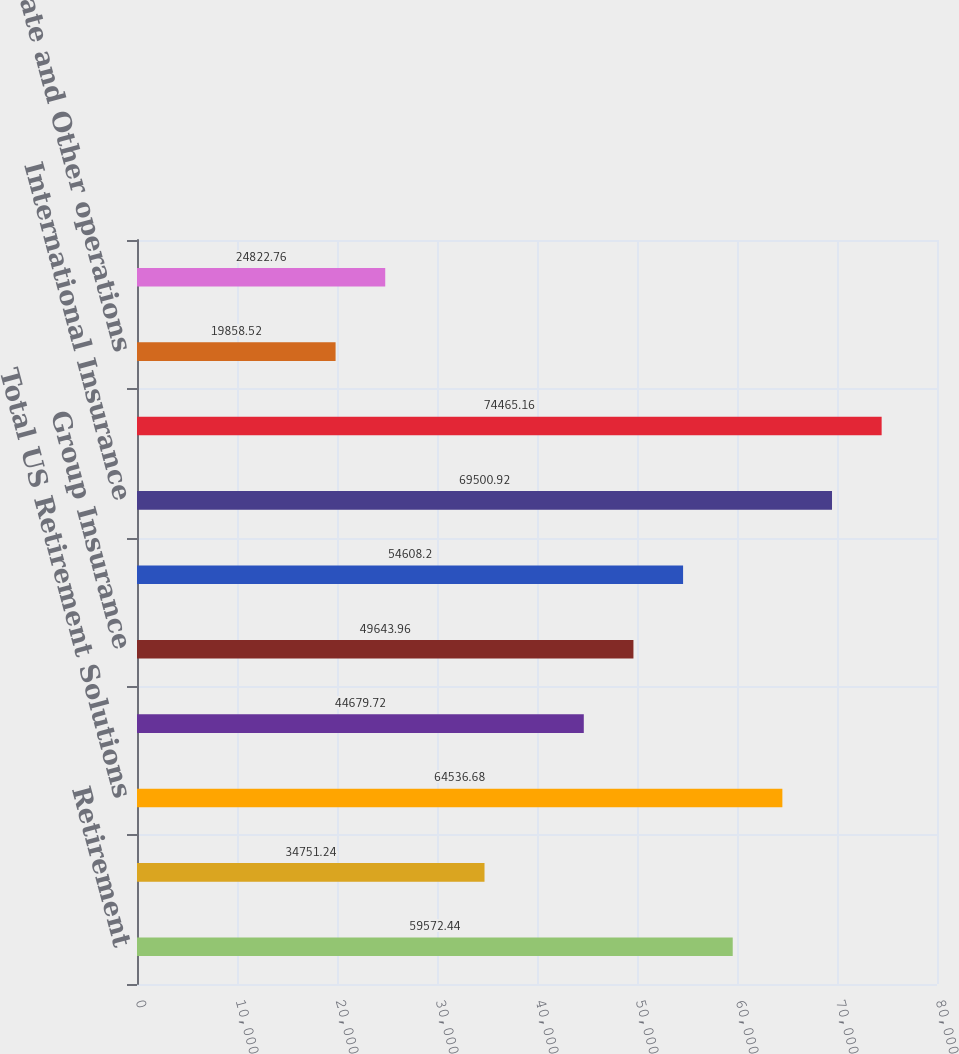Convert chart. <chart><loc_0><loc_0><loc_500><loc_500><bar_chart><fcel>Retirement<fcel>Asset Management<fcel>Total US Retirement Solutions<fcel>Individual Life<fcel>Group Insurance<fcel>Total US Individual Life and<fcel>International Insurance<fcel>Total International Insurance<fcel>Corporate and Other operations<fcel>Total Corporate and Other<nl><fcel>59572.4<fcel>34751.2<fcel>64536.7<fcel>44679.7<fcel>49644<fcel>54608.2<fcel>69500.9<fcel>74465.2<fcel>19858.5<fcel>24822.8<nl></chart> 